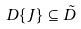<formula> <loc_0><loc_0><loc_500><loc_500>D \{ J \} \subseteq \tilde { D }</formula> 